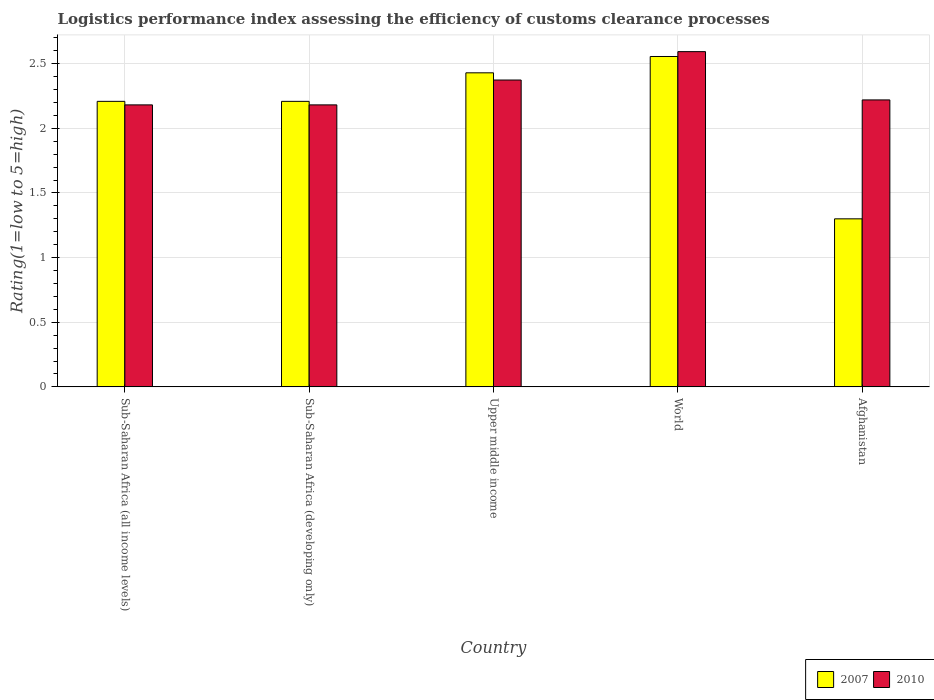Are the number of bars per tick equal to the number of legend labels?
Your response must be concise. Yes. Are the number of bars on each tick of the X-axis equal?
Make the answer very short. Yes. How many bars are there on the 4th tick from the right?
Offer a very short reply. 2. What is the label of the 1st group of bars from the left?
Ensure brevity in your answer.  Sub-Saharan Africa (all income levels). In how many cases, is the number of bars for a given country not equal to the number of legend labels?
Provide a succinct answer. 0. What is the Logistic performance index in 2007 in World?
Make the answer very short. 2.56. Across all countries, what is the maximum Logistic performance index in 2010?
Make the answer very short. 2.59. In which country was the Logistic performance index in 2010 minimum?
Offer a terse response. Sub-Saharan Africa (all income levels). What is the total Logistic performance index in 2010 in the graph?
Your response must be concise. 11.55. What is the difference between the Logistic performance index in 2007 in Sub-Saharan Africa (developing only) and that in World?
Provide a succinct answer. -0.35. What is the difference between the Logistic performance index in 2007 in Afghanistan and the Logistic performance index in 2010 in World?
Give a very brief answer. -1.29. What is the average Logistic performance index in 2007 per country?
Provide a succinct answer. 2.14. What is the difference between the Logistic performance index of/in 2010 and Logistic performance index of/in 2007 in Afghanistan?
Provide a short and direct response. 0.92. What is the ratio of the Logistic performance index in 2010 in Sub-Saharan Africa (developing only) to that in World?
Keep it short and to the point. 0.84. Is the Logistic performance index in 2007 in Sub-Saharan Africa (developing only) less than that in World?
Provide a succinct answer. Yes. What is the difference between the highest and the second highest Logistic performance index in 2010?
Your answer should be compact. 0.22. What is the difference between the highest and the lowest Logistic performance index in 2010?
Keep it short and to the point. 0.41. Is the sum of the Logistic performance index in 2007 in Sub-Saharan Africa (all income levels) and World greater than the maximum Logistic performance index in 2010 across all countries?
Offer a very short reply. Yes. What does the 1st bar from the left in Sub-Saharan Africa (all income levels) represents?
Your answer should be very brief. 2007. How many bars are there?
Provide a short and direct response. 10. Are all the bars in the graph horizontal?
Ensure brevity in your answer.  No. How many countries are there in the graph?
Give a very brief answer. 5. Are the values on the major ticks of Y-axis written in scientific E-notation?
Offer a very short reply. No. Does the graph contain any zero values?
Ensure brevity in your answer.  No. Where does the legend appear in the graph?
Ensure brevity in your answer.  Bottom right. How many legend labels are there?
Make the answer very short. 2. What is the title of the graph?
Give a very brief answer. Logistics performance index assessing the efficiency of customs clearance processes. What is the label or title of the X-axis?
Give a very brief answer. Country. What is the label or title of the Y-axis?
Your response must be concise. Rating(1=low to 5=high). What is the Rating(1=low to 5=high) in 2007 in Sub-Saharan Africa (all income levels)?
Provide a short and direct response. 2.21. What is the Rating(1=low to 5=high) in 2010 in Sub-Saharan Africa (all income levels)?
Keep it short and to the point. 2.18. What is the Rating(1=low to 5=high) in 2007 in Sub-Saharan Africa (developing only)?
Provide a short and direct response. 2.21. What is the Rating(1=low to 5=high) in 2010 in Sub-Saharan Africa (developing only)?
Give a very brief answer. 2.18. What is the Rating(1=low to 5=high) of 2007 in Upper middle income?
Provide a succinct answer. 2.43. What is the Rating(1=low to 5=high) in 2010 in Upper middle income?
Offer a very short reply. 2.37. What is the Rating(1=low to 5=high) in 2007 in World?
Provide a short and direct response. 2.56. What is the Rating(1=low to 5=high) of 2010 in World?
Provide a succinct answer. 2.59. What is the Rating(1=low to 5=high) of 2007 in Afghanistan?
Ensure brevity in your answer.  1.3. What is the Rating(1=low to 5=high) in 2010 in Afghanistan?
Provide a succinct answer. 2.22. Across all countries, what is the maximum Rating(1=low to 5=high) in 2007?
Provide a succinct answer. 2.56. Across all countries, what is the maximum Rating(1=low to 5=high) of 2010?
Offer a very short reply. 2.59. Across all countries, what is the minimum Rating(1=low to 5=high) of 2007?
Provide a succinct answer. 1.3. Across all countries, what is the minimum Rating(1=low to 5=high) in 2010?
Your answer should be compact. 2.18. What is the total Rating(1=low to 5=high) in 2007 in the graph?
Offer a very short reply. 10.7. What is the total Rating(1=low to 5=high) of 2010 in the graph?
Ensure brevity in your answer.  11.55. What is the difference between the Rating(1=low to 5=high) in 2010 in Sub-Saharan Africa (all income levels) and that in Sub-Saharan Africa (developing only)?
Your answer should be very brief. 0. What is the difference between the Rating(1=low to 5=high) of 2007 in Sub-Saharan Africa (all income levels) and that in Upper middle income?
Offer a very short reply. -0.22. What is the difference between the Rating(1=low to 5=high) of 2010 in Sub-Saharan Africa (all income levels) and that in Upper middle income?
Your response must be concise. -0.19. What is the difference between the Rating(1=low to 5=high) of 2007 in Sub-Saharan Africa (all income levels) and that in World?
Offer a very short reply. -0.35. What is the difference between the Rating(1=low to 5=high) of 2010 in Sub-Saharan Africa (all income levels) and that in World?
Your response must be concise. -0.41. What is the difference between the Rating(1=low to 5=high) of 2007 in Sub-Saharan Africa (all income levels) and that in Afghanistan?
Provide a short and direct response. 0.91. What is the difference between the Rating(1=low to 5=high) in 2010 in Sub-Saharan Africa (all income levels) and that in Afghanistan?
Provide a short and direct response. -0.04. What is the difference between the Rating(1=low to 5=high) of 2007 in Sub-Saharan Africa (developing only) and that in Upper middle income?
Offer a terse response. -0.22. What is the difference between the Rating(1=low to 5=high) of 2010 in Sub-Saharan Africa (developing only) and that in Upper middle income?
Your answer should be very brief. -0.19. What is the difference between the Rating(1=low to 5=high) of 2007 in Sub-Saharan Africa (developing only) and that in World?
Offer a very short reply. -0.35. What is the difference between the Rating(1=low to 5=high) in 2010 in Sub-Saharan Africa (developing only) and that in World?
Keep it short and to the point. -0.41. What is the difference between the Rating(1=low to 5=high) of 2007 in Sub-Saharan Africa (developing only) and that in Afghanistan?
Your response must be concise. 0.91. What is the difference between the Rating(1=low to 5=high) of 2010 in Sub-Saharan Africa (developing only) and that in Afghanistan?
Your answer should be compact. -0.04. What is the difference between the Rating(1=low to 5=high) in 2007 in Upper middle income and that in World?
Your answer should be compact. -0.13. What is the difference between the Rating(1=low to 5=high) of 2010 in Upper middle income and that in World?
Your answer should be compact. -0.22. What is the difference between the Rating(1=low to 5=high) in 2007 in Upper middle income and that in Afghanistan?
Your answer should be compact. 1.13. What is the difference between the Rating(1=low to 5=high) in 2010 in Upper middle income and that in Afghanistan?
Your answer should be compact. 0.15. What is the difference between the Rating(1=low to 5=high) of 2007 in World and that in Afghanistan?
Your answer should be compact. 1.26. What is the difference between the Rating(1=low to 5=high) of 2010 in World and that in Afghanistan?
Your answer should be compact. 0.37. What is the difference between the Rating(1=low to 5=high) of 2007 in Sub-Saharan Africa (all income levels) and the Rating(1=low to 5=high) of 2010 in Sub-Saharan Africa (developing only)?
Ensure brevity in your answer.  0.03. What is the difference between the Rating(1=low to 5=high) in 2007 in Sub-Saharan Africa (all income levels) and the Rating(1=low to 5=high) in 2010 in Upper middle income?
Your response must be concise. -0.16. What is the difference between the Rating(1=low to 5=high) of 2007 in Sub-Saharan Africa (all income levels) and the Rating(1=low to 5=high) of 2010 in World?
Offer a very short reply. -0.38. What is the difference between the Rating(1=low to 5=high) of 2007 in Sub-Saharan Africa (all income levels) and the Rating(1=low to 5=high) of 2010 in Afghanistan?
Provide a succinct answer. -0.01. What is the difference between the Rating(1=low to 5=high) in 2007 in Sub-Saharan Africa (developing only) and the Rating(1=low to 5=high) in 2010 in Upper middle income?
Make the answer very short. -0.16. What is the difference between the Rating(1=low to 5=high) of 2007 in Sub-Saharan Africa (developing only) and the Rating(1=low to 5=high) of 2010 in World?
Ensure brevity in your answer.  -0.38. What is the difference between the Rating(1=low to 5=high) in 2007 in Sub-Saharan Africa (developing only) and the Rating(1=low to 5=high) in 2010 in Afghanistan?
Give a very brief answer. -0.01. What is the difference between the Rating(1=low to 5=high) in 2007 in Upper middle income and the Rating(1=low to 5=high) in 2010 in World?
Ensure brevity in your answer.  -0.16. What is the difference between the Rating(1=low to 5=high) of 2007 in Upper middle income and the Rating(1=low to 5=high) of 2010 in Afghanistan?
Your answer should be very brief. 0.21. What is the difference between the Rating(1=low to 5=high) in 2007 in World and the Rating(1=low to 5=high) in 2010 in Afghanistan?
Provide a short and direct response. 0.34. What is the average Rating(1=low to 5=high) of 2007 per country?
Offer a very short reply. 2.14. What is the average Rating(1=low to 5=high) in 2010 per country?
Your response must be concise. 2.31. What is the difference between the Rating(1=low to 5=high) of 2007 and Rating(1=low to 5=high) of 2010 in Sub-Saharan Africa (all income levels)?
Provide a succinct answer. 0.03. What is the difference between the Rating(1=low to 5=high) in 2007 and Rating(1=low to 5=high) in 2010 in Sub-Saharan Africa (developing only)?
Offer a terse response. 0.03. What is the difference between the Rating(1=low to 5=high) of 2007 and Rating(1=low to 5=high) of 2010 in Upper middle income?
Keep it short and to the point. 0.06. What is the difference between the Rating(1=low to 5=high) in 2007 and Rating(1=low to 5=high) in 2010 in World?
Your response must be concise. -0.04. What is the difference between the Rating(1=low to 5=high) in 2007 and Rating(1=low to 5=high) in 2010 in Afghanistan?
Provide a succinct answer. -0.92. What is the ratio of the Rating(1=low to 5=high) in 2007 in Sub-Saharan Africa (all income levels) to that in Sub-Saharan Africa (developing only)?
Your answer should be compact. 1. What is the ratio of the Rating(1=low to 5=high) in 2007 in Sub-Saharan Africa (all income levels) to that in Upper middle income?
Ensure brevity in your answer.  0.91. What is the ratio of the Rating(1=low to 5=high) in 2010 in Sub-Saharan Africa (all income levels) to that in Upper middle income?
Your answer should be compact. 0.92. What is the ratio of the Rating(1=low to 5=high) in 2007 in Sub-Saharan Africa (all income levels) to that in World?
Provide a short and direct response. 0.86. What is the ratio of the Rating(1=low to 5=high) of 2010 in Sub-Saharan Africa (all income levels) to that in World?
Your answer should be very brief. 0.84. What is the ratio of the Rating(1=low to 5=high) in 2007 in Sub-Saharan Africa (all income levels) to that in Afghanistan?
Provide a succinct answer. 1.7. What is the ratio of the Rating(1=low to 5=high) in 2010 in Sub-Saharan Africa (all income levels) to that in Afghanistan?
Offer a very short reply. 0.98. What is the ratio of the Rating(1=low to 5=high) of 2007 in Sub-Saharan Africa (developing only) to that in Upper middle income?
Your answer should be compact. 0.91. What is the ratio of the Rating(1=low to 5=high) in 2010 in Sub-Saharan Africa (developing only) to that in Upper middle income?
Your answer should be compact. 0.92. What is the ratio of the Rating(1=low to 5=high) of 2007 in Sub-Saharan Africa (developing only) to that in World?
Your response must be concise. 0.86. What is the ratio of the Rating(1=low to 5=high) of 2010 in Sub-Saharan Africa (developing only) to that in World?
Your answer should be compact. 0.84. What is the ratio of the Rating(1=low to 5=high) of 2007 in Sub-Saharan Africa (developing only) to that in Afghanistan?
Your answer should be compact. 1.7. What is the ratio of the Rating(1=low to 5=high) in 2010 in Sub-Saharan Africa (developing only) to that in Afghanistan?
Offer a terse response. 0.98. What is the ratio of the Rating(1=low to 5=high) in 2007 in Upper middle income to that in World?
Give a very brief answer. 0.95. What is the ratio of the Rating(1=low to 5=high) in 2010 in Upper middle income to that in World?
Your answer should be very brief. 0.92. What is the ratio of the Rating(1=low to 5=high) of 2007 in Upper middle income to that in Afghanistan?
Make the answer very short. 1.87. What is the ratio of the Rating(1=low to 5=high) in 2010 in Upper middle income to that in Afghanistan?
Make the answer very short. 1.07. What is the ratio of the Rating(1=low to 5=high) in 2007 in World to that in Afghanistan?
Your answer should be very brief. 1.97. What is the ratio of the Rating(1=low to 5=high) of 2010 in World to that in Afghanistan?
Make the answer very short. 1.17. What is the difference between the highest and the second highest Rating(1=low to 5=high) of 2007?
Offer a very short reply. 0.13. What is the difference between the highest and the second highest Rating(1=low to 5=high) of 2010?
Offer a terse response. 0.22. What is the difference between the highest and the lowest Rating(1=low to 5=high) of 2007?
Ensure brevity in your answer.  1.26. What is the difference between the highest and the lowest Rating(1=low to 5=high) in 2010?
Your answer should be compact. 0.41. 